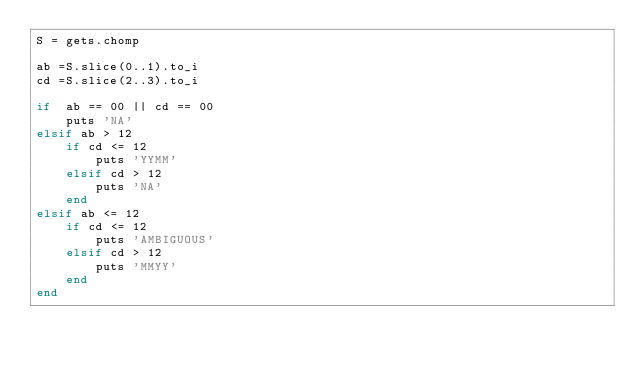Convert code to text. <code><loc_0><loc_0><loc_500><loc_500><_Ruby_>S = gets.chomp

ab =S.slice(0..1).to_i
cd =S.slice(2..3).to_i

if  ab == 00 || cd == 00
    puts 'NA'
elsif ab > 12 
    if cd <= 12
        puts 'YYMM'
    elsif cd > 12 
        puts 'NA'
    end
elsif ab <= 12
    if cd <= 12
        puts 'AMBIGUOUS'
    elsif cd > 12
        puts 'MMYY'
    end
end

</code> 